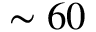Convert formula to latex. <formula><loc_0><loc_0><loc_500><loc_500>\sim 6 0</formula> 